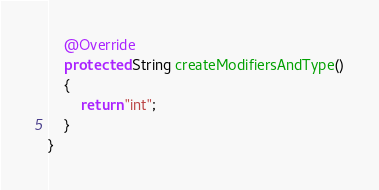<code> <loc_0><loc_0><loc_500><loc_500><_Java_>

    @Override
    protected String createModifiersAndType()
    {
        return "int";
    }
}
</code> 